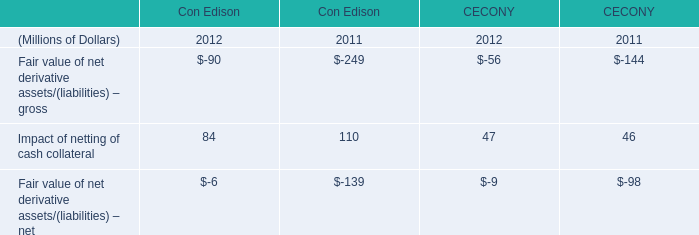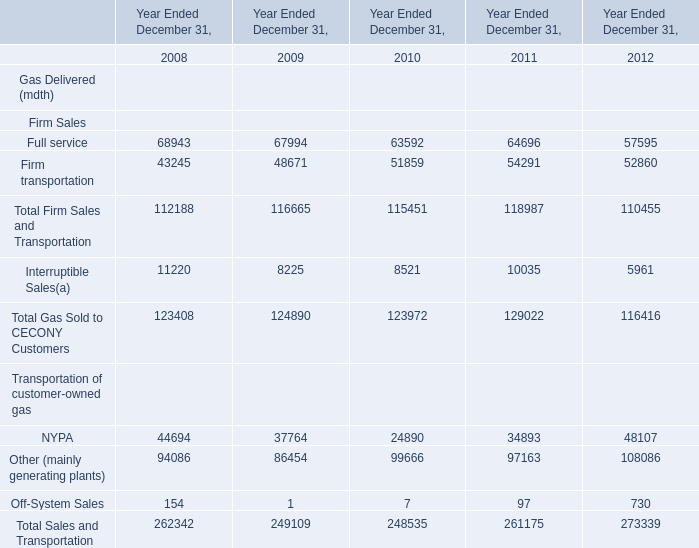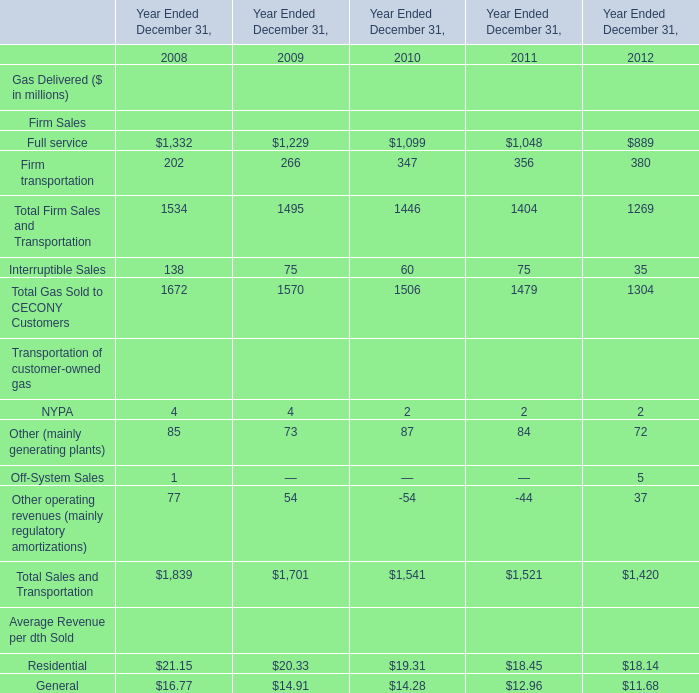In the year with lowest amount of Firm transportation, what's the increasing rate of Full service？ 
Computations: ((67994 - 68943) / 68943)
Answer: -0.01376. 